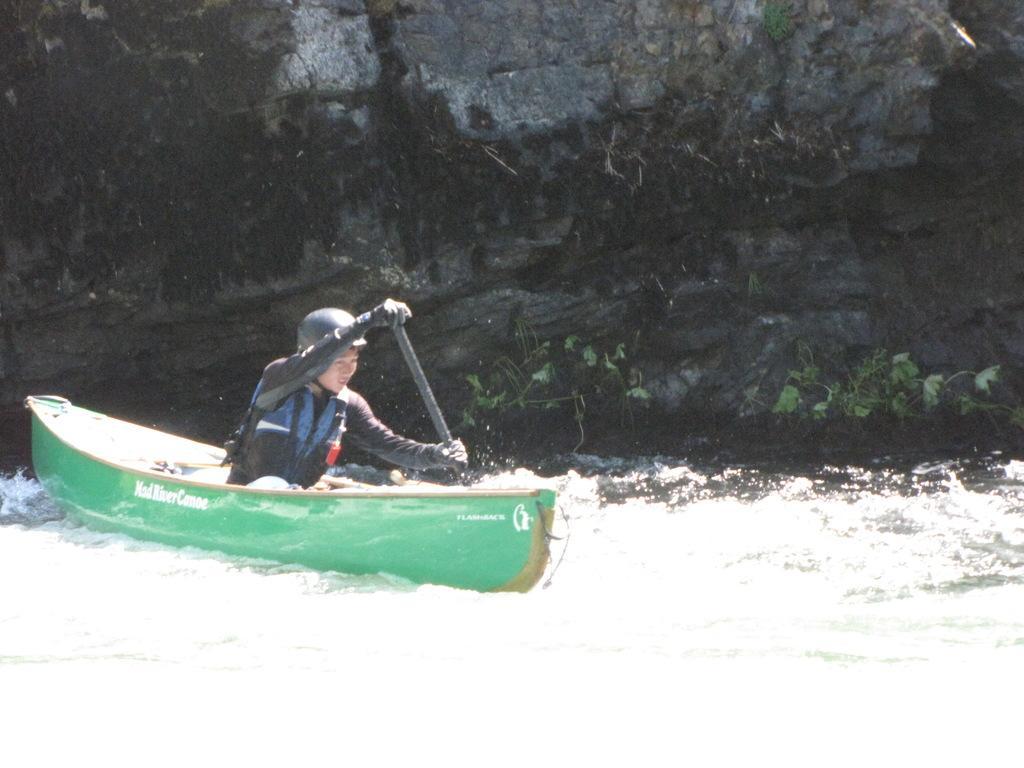How would you summarize this image in a sentence or two? In this image, we can see a man sitting on the boat and rowing in the water. In the background, we can see a rock. 